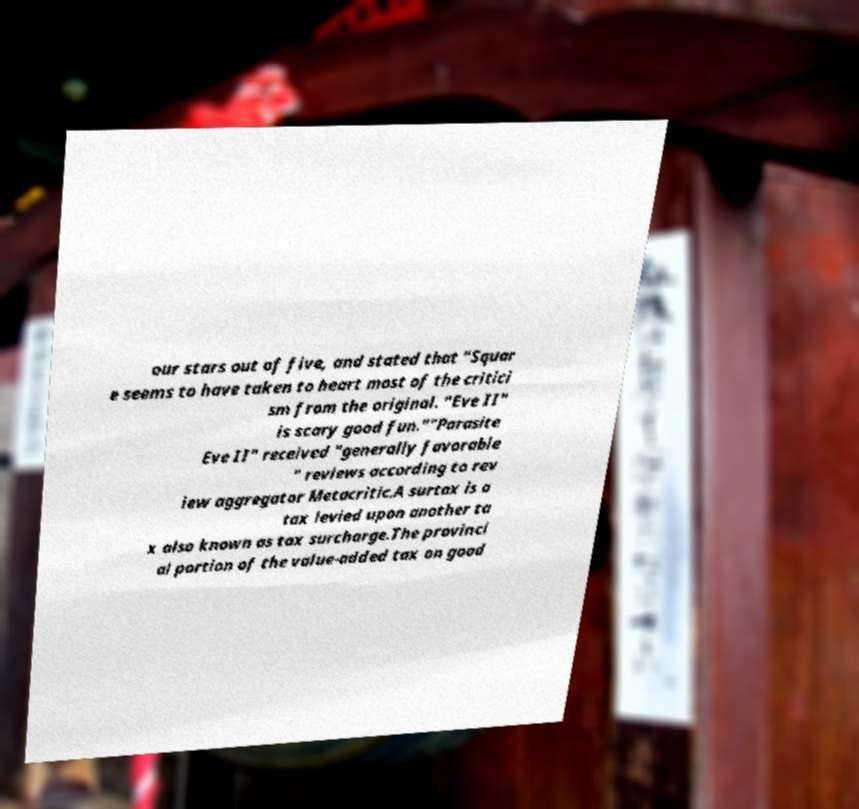There's text embedded in this image that I need extracted. Can you transcribe it verbatim? our stars out of five, and stated that "Squar e seems to have taken to heart most of the critici sm from the original. "Eve II" is scary good fun.""Parasite Eve II" received "generally favorable " reviews according to rev iew aggregator Metacritic.A surtax is a tax levied upon another ta x also known as tax surcharge.The provinci al portion of the value-added tax on good 